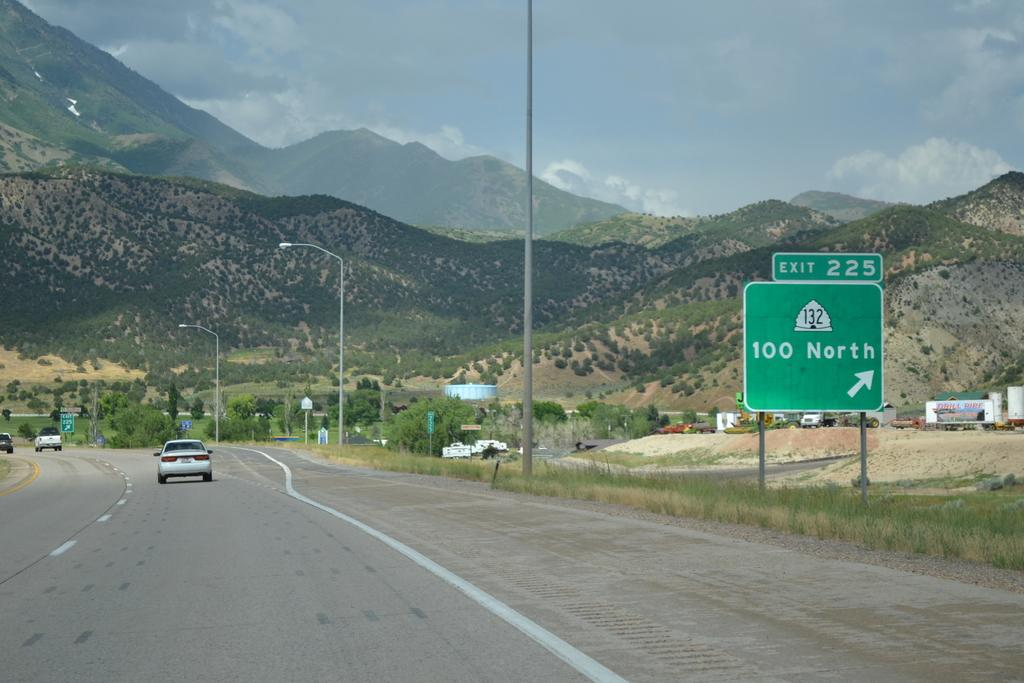<image>
Describe the image concisely. Exit 225 for 100 North is noted on a green street sign. 